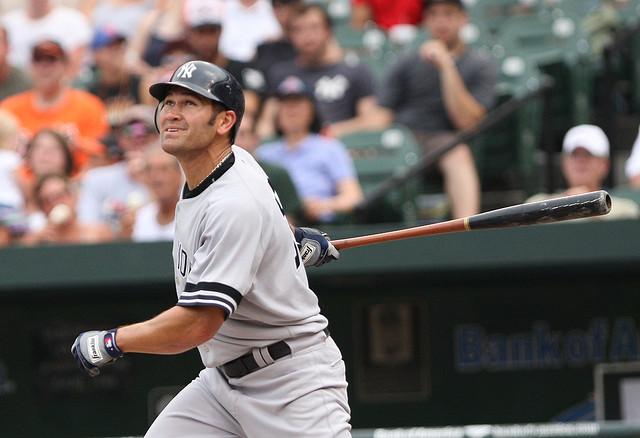Does he has a beard?
Short answer required. No. What color are the seats in the stadium?
Quick response, please. Green. What sport is he playing?
Answer briefly. Baseball. What is he holding?
Be succinct. Bat. Is the man in motion?
Short answer required. Yes. Is he looking up or down?
Write a very short answer. Up. What color is the bat?
Answer briefly. Brown and black. 